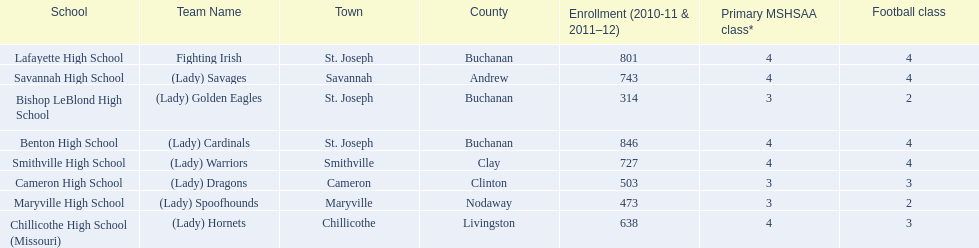What team uses green and grey as colors? Fighting Irish. What is this team called? Lafayette High School. 